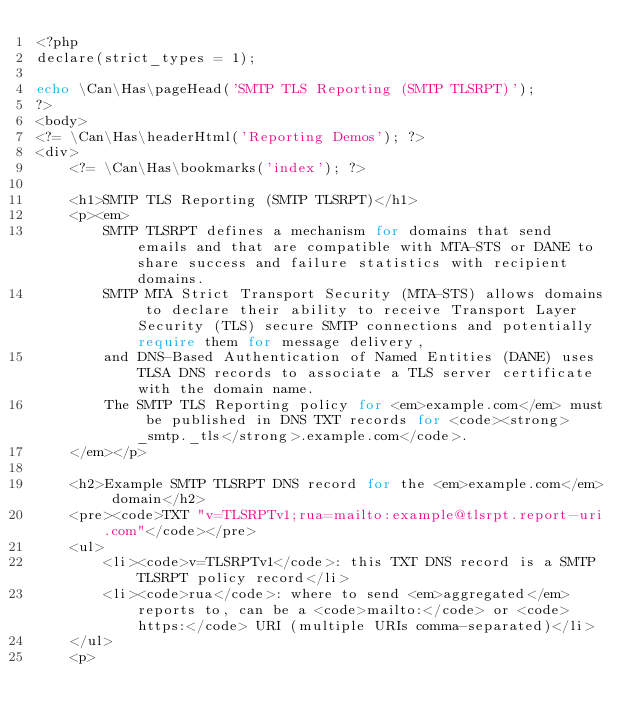Convert code to text. <code><loc_0><loc_0><loc_500><loc_500><_PHP_><?php
declare(strict_types = 1);

echo \Can\Has\pageHead('SMTP TLS Reporting (SMTP TLSRPT)');
?>
<body>
<?= \Can\Has\headerHtml('Reporting Demos'); ?>
<div>
	<?= \Can\Has\bookmarks('index'); ?>

	<h1>SMTP TLS Reporting (SMTP TLSRPT)</h1>
	<p><em>
		SMTP TLSRPT defines a mechanism for domains that send emails and that are compatible with MTA-STS or DANE to share success and failure statistics with recipient domains.
		SMTP MTA Strict Transport Security (MTA-STS) allows domains to declare their ability to receive Transport Layer Security (TLS) secure SMTP connections and potentially require them for message delivery,
		and DNS-Based Authentication of Named Entities (DANE) uses TLSA DNS records to associate a TLS server certificate with the domain name.
		The SMTP TLS Reporting policy for <em>example.com</em> must be published in DNS TXT records for <code><strong>_smtp._tls</strong>.example.com</code>.
	</em></p>

	<h2>Example SMTP TLSRPT DNS record for the <em>example.com</em> domain</h2>
	<pre><code>TXT "v=TLSRPTv1;rua=mailto:example@tlsrpt.report-uri.com"</code></pre>
	<ul>
		<li><code>v=TLSRPTv1</code>: this TXT DNS record is a SMTP TLSRPT policy record</li>
		<li><code>rua</code>: where to send <em>aggregated</em> reports to, can be a <code>mailto:</code> or <code>https:</code> URI (multiple URIs comma-separated)</li>
	</ul>
	<p></code> 